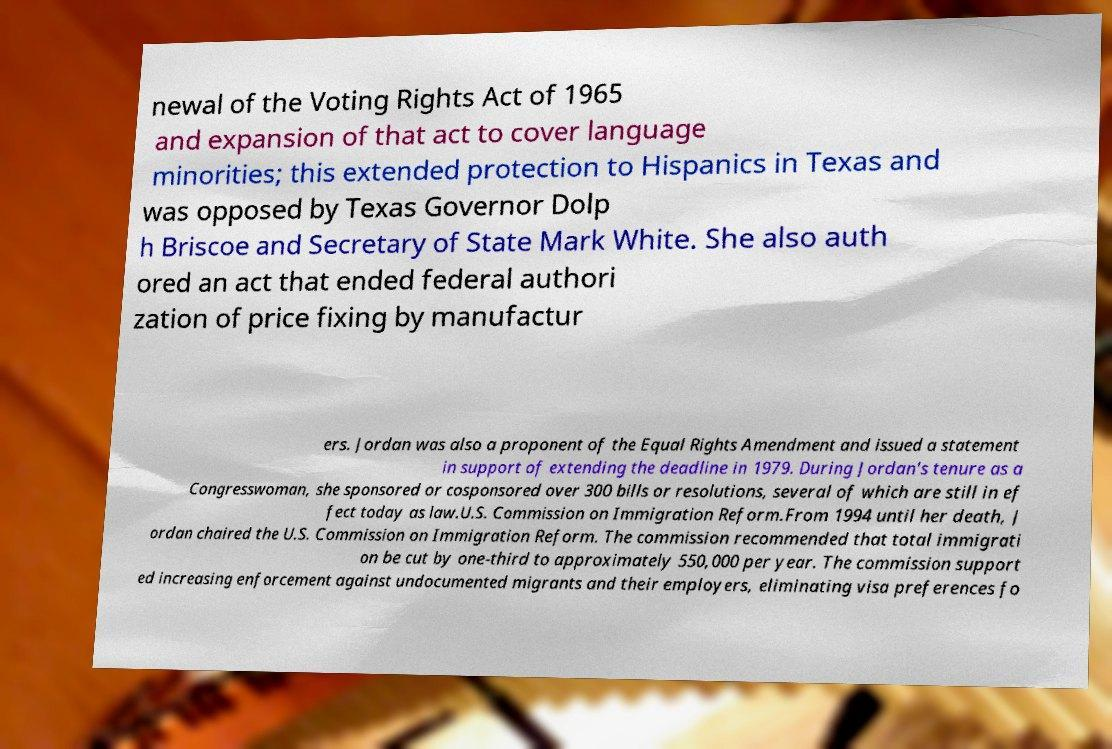Can you read and provide the text displayed in the image?This photo seems to have some interesting text. Can you extract and type it out for me? newal of the Voting Rights Act of 1965 and expansion of that act to cover language minorities; this extended protection to Hispanics in Texas and was opposed by Texas Governor Dolp h Briscoe and Secretary of State Mark White. She also auth ored an act that ended federal authori zation of price fixing by manufactur ers. Jordan was also a proponent of the Equal Rights Amendment and issued a statement in support of extending the deadline in 1979. During Jordan's tenure as a Congresswoman, she sponsored or cosponsored over 300 bills or resolutions, several of which are still in ef fect today as law.U.S. Commission on Immigration Reform.From 1994 until her death, J ordan chaired the U.S. Commission on Immigration Reform. The commission recommended that total immigrati on be cut by one-third to approximately 550,000 per year. The commission support ed increasing enforcement against undocumented migrants and their employers, eliminating visa preferences fo 